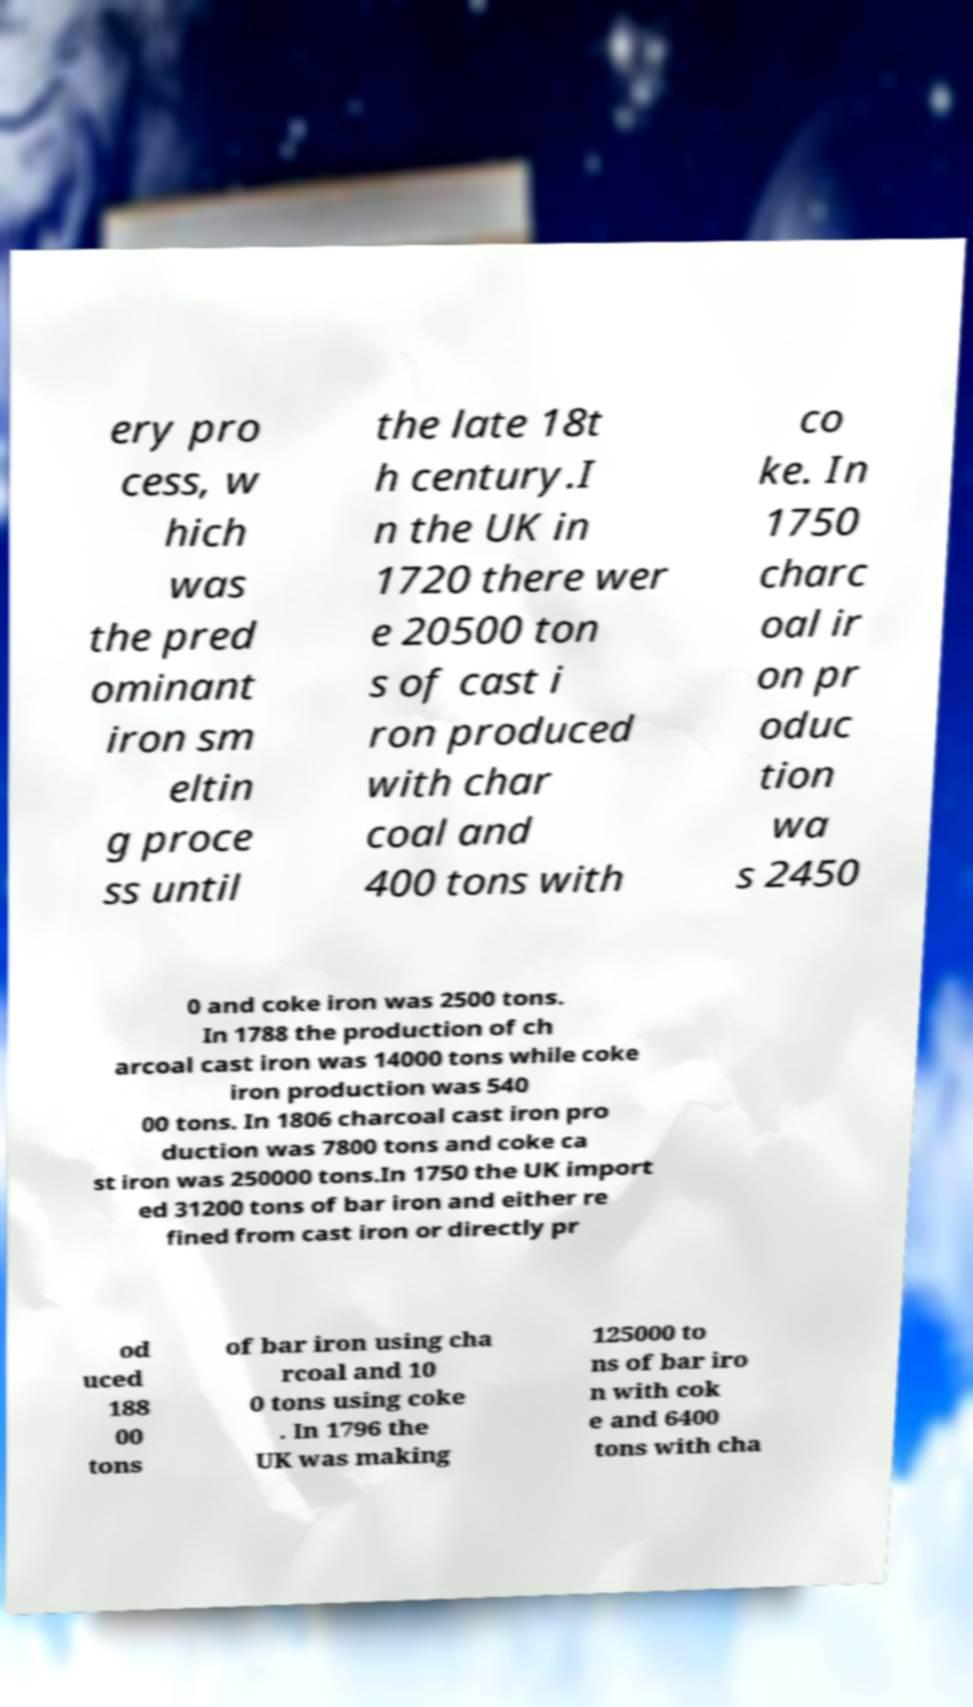Can you accurately transcribe the text from the provided image for me? ery pro cess, w hich was the pred ominant iron sm eltin g proce ss until the late 18t h century.I n the UK in 1720 there wer e 20500 ton s of cast i ron produced with char coal and 400 tons with co ke. In 1750 charc oal ir on pr oduc tion wa s 2450 0 and coke iron was 2500 tons. In 1788 the production of ch arcoal cast iron was 14000 tons while coke iron production was 540 00 tons. In 1806 charcoal cast iron pro duction was 7800 tons and coke ca st iron was 250000 tons.In 1750 the UK import ed 31200 tons of bar iron and either re fined from cast iron or directly pr od uced 188 00 tons of bar iron using cha rcoal and 10 0 tons using coke . In 1796 the UK was making 125000 to ns of bar iro n with cok e and 6400 tons with cha 